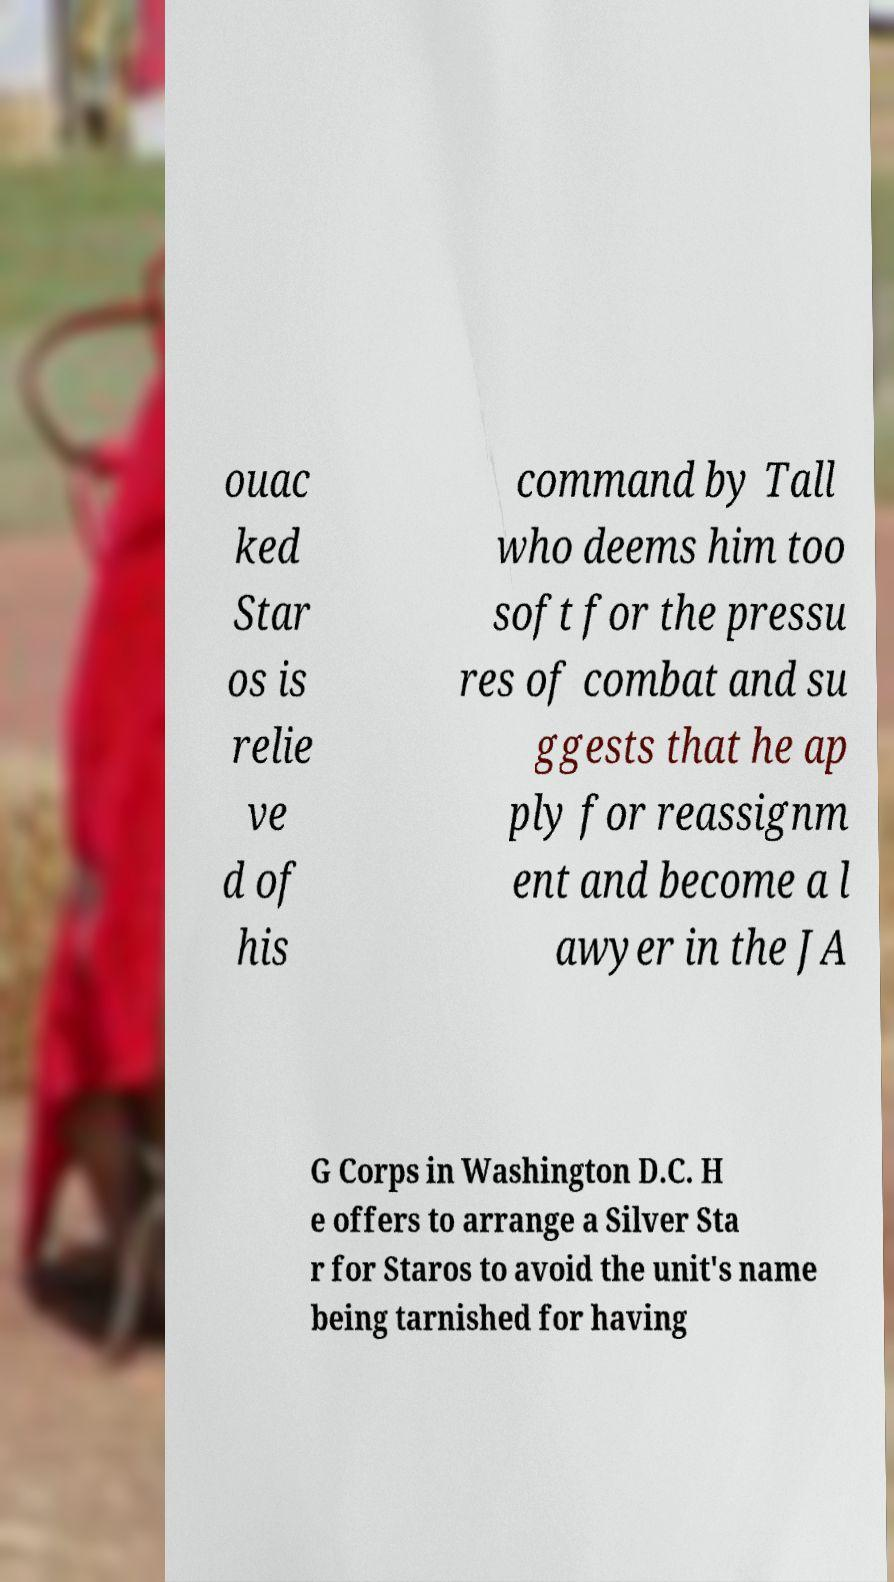For documentation purposes, I need the text within this image transcribed. Could you provide that? ouac ked Star os is relie ve d of his command by Tall who deems him too soft for the pressu res of combat and su ggests that he ap ply for reassignm ent and become a l awyer in the JA G Corps in Washington D.C. H e offers to arrange a Silver Sta r for Staros to avoid the unit's name being tarnished for having 